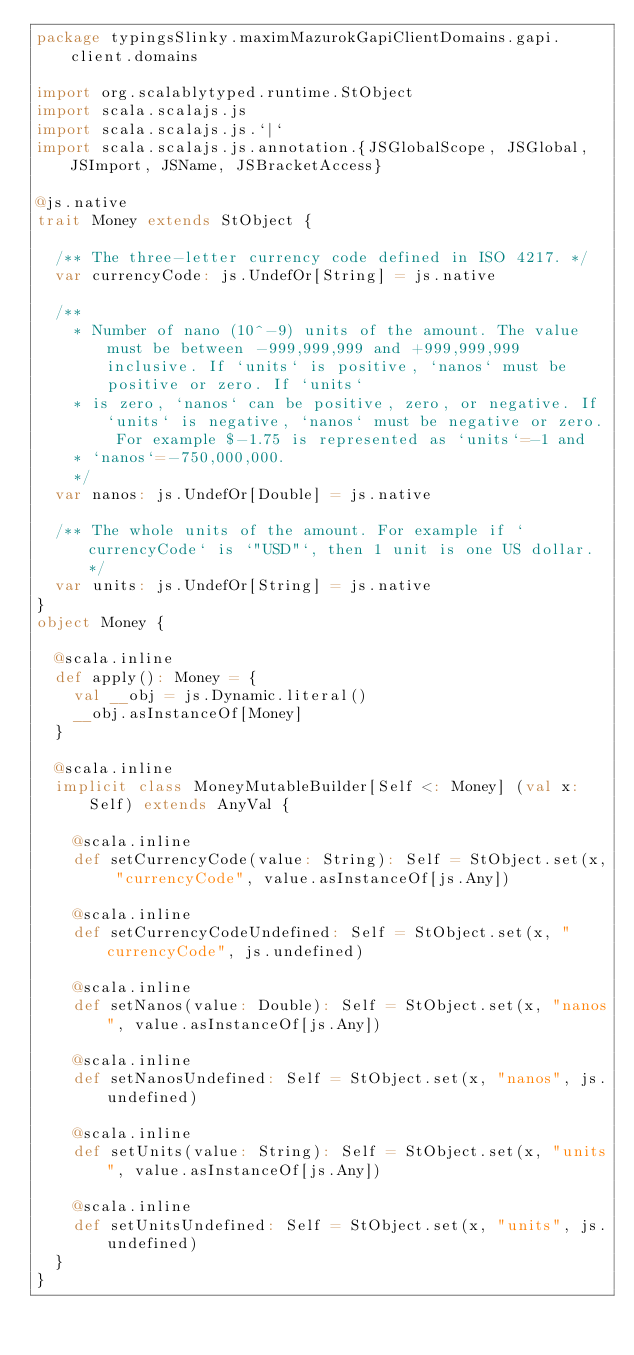<code> <loc_0><loc_0><loc_500><loc_500><_Scala_>package typingsSlinky.maximMazurokGapiClientDomains.gapi.client.domains

import org.scalablytyped.runtime.StObject
import scala.scalajs.js
import scala.scalajs.js.`|`
import scala.scalajs.js.annotation.{JSGlobalScope, JSGlobal, JSImport, JSName, JSBracketAccess}

@js.native
trait Money extends StObject {
  
  /** The three-letter currency code defined in ISO 4217. */
  var currencyCode: js.UndefOr[String] = js.native
  
  /**
    * Number of nano (10^-9) units of the amount. The value must be between -999,999,999 and +999,999,999 inclusive. If `units` is positive, `nanos` must be positive or zero. If `units`
    * is zero, `nanos` can be positive, zero, or negative. If `units` is negative, `nanos` must be negative or zero. For example $-1.75 is represented as `units`=-1 and
    * `nanos`=-750,000,000.
    */
  var nanos: js.UndefOr[Double] = js.native
  
  /** The whole units of the amount. For example if `currencyCode` is `"USD"`, then 1 unit is one US dollar. */
  var units: js.UndefOr[String] = js.native
}
object Money {
  
  @scala.inline
  def apply(): Money = {
    val __obj = js.Dynamic.literal()
    __obj.asInstanceOf[Money]
  }
  
  @scala.inline
  implicit class MoneyMutableBuilder[Self <: Money] (val x: Self) extends AnyVal {
    
    @scala.inline
    def setCurrencyCode(value: String): Self = StObject.set(x, "currencyCode", value.asInstanceOf[js.Any])
    
    @scala.inline
    def setCurrencyCodeUndefined: Self = StObject.set(x, "currencyCode", js.undefined)
    
    @scala.inline
    def setNanos(value: Double): Self = StObject.set(x, "nanos", value.asInstanceOf[js.Any])
    
    @scala.inline
    def setNanosUndefined: Self = StObject.set(x, "nanos", js.undefined)
    
    @scala.inline
    def setUnits(value: String): Self = StObject.set(x, "units", value.asInstanceOf[js.Any])
    
    @scala.inline
    def setUnitsUndefined: Self = StObject.set(x, "units", js.undefined)
  }
}
</code> 